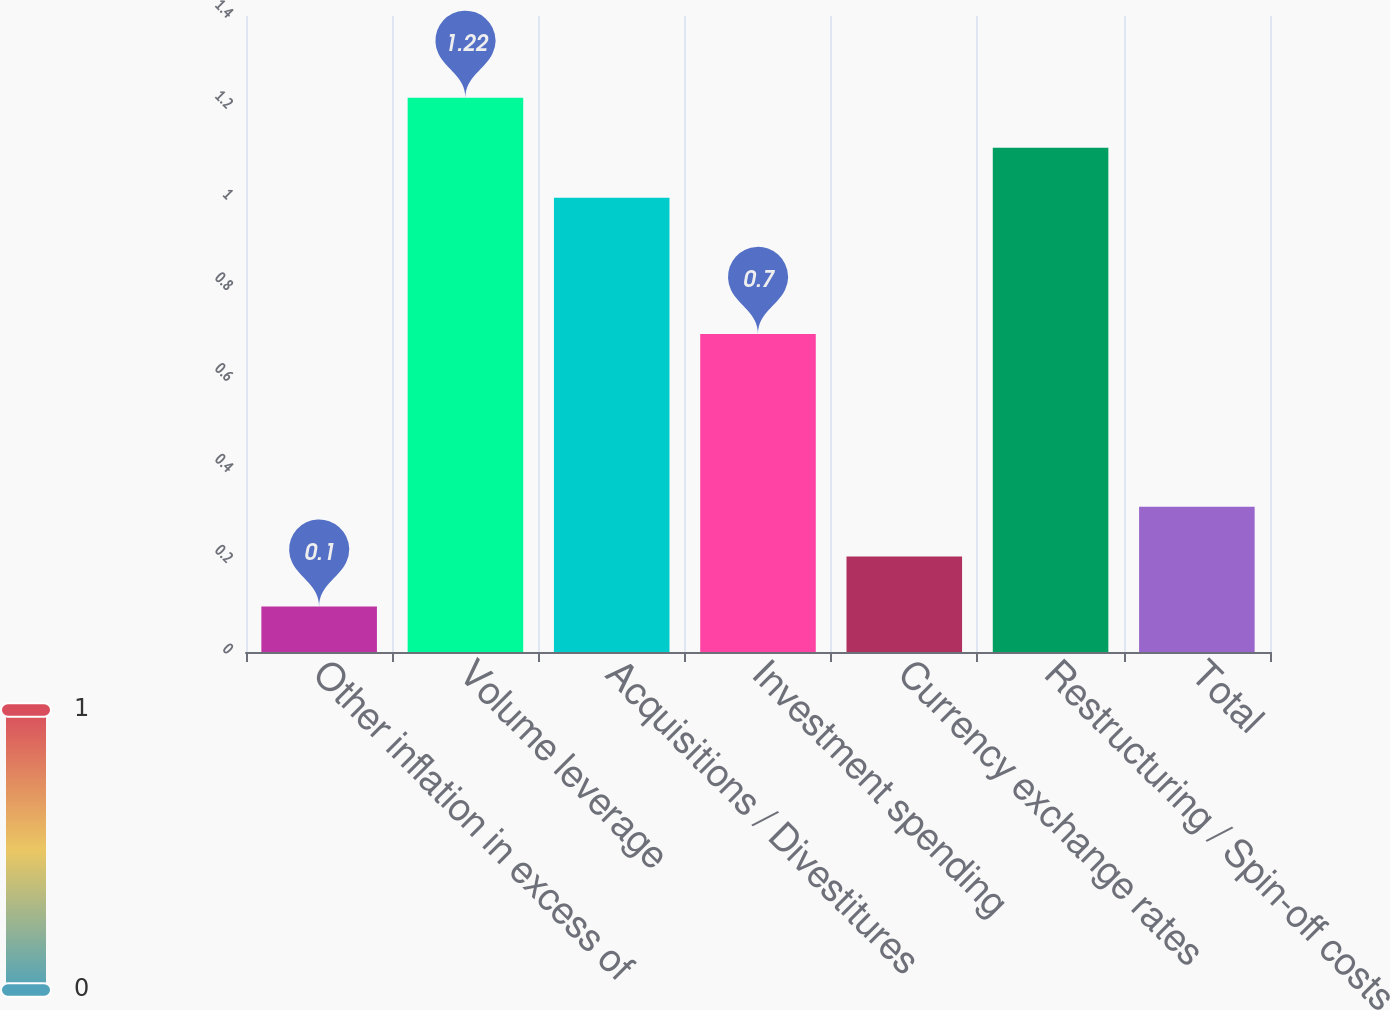<chart> <loc_0><loc_0><loc_500><loc_500><bar_chart><fcel>Other inflation in excess of<fcel>Volume leverage<fcel>Acquisitions / Divestitures<fcel>Investment spending<fcel>Currency exchange rates<fcel>Restructuring / Spin-off costs<fcel>Total<nl><fcel>0.1<fcel>1.22<fcel>1<fcel>0.7<fcel>0.21<fcel>1.11<fcel>0.32<nl></chart> 